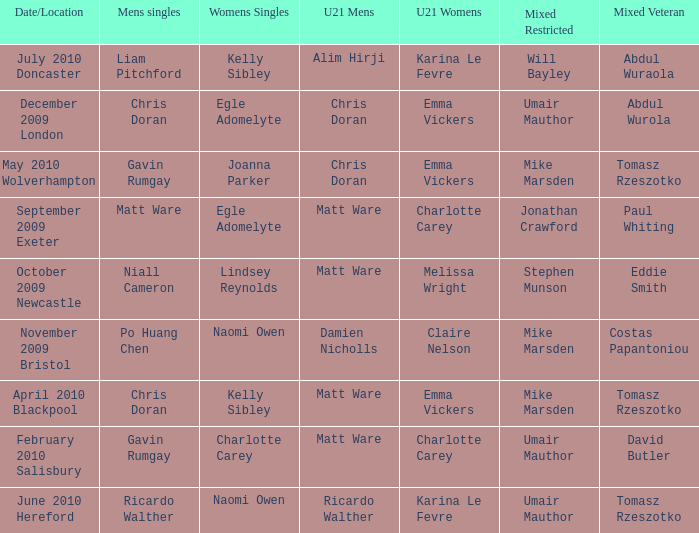Who won the mixed restricted when Tomasz Rzeszotko won the mixed veteran and Karina Le Fevre won the U21 womens? Umair Mauthor. 